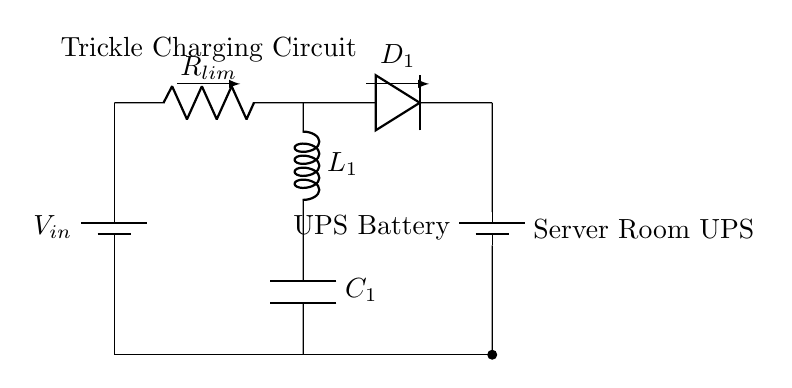What is the input voltage in the circuit? The input voltage is represented as V in the circuit diagram, which typically indicates the supply voltage.
Answer: V in What type of resistor is used in this circuit? The diagram shows a current limiting resistor labeled R lim, which limits the current through the circuit.
Answer: Current limiting resistor What component is responsible for rectifying the current? The component labeled D 1 in the diagram indicates a diode, which allows current to flow in one direction, effectively rectifying the current.
Answer: Diode How many inductors are in this circuit? The circuit shows one inductor labeled L 1, which is used for filtering or energy storage.
Answer: One What is the purpose of the capacitor in this circuit? The capacitor, labeled C 1, is used to smooth out voltage fluctuations and maintain a stable voltage to the battery.
Answer: Smoothing voltage How many batteries are shown in the circuit? The diagram indicates two batteries: one as the power supply and one labeled UPS Battery, hence there are two batteries in total.
Answer: Two What is the overall function of this circuit? The circuit is designed for trickle charging the UPS battery, ensuring that the battery is kept at a stable charge level without overcharging.
Answer: Trickle charging UPS battery 